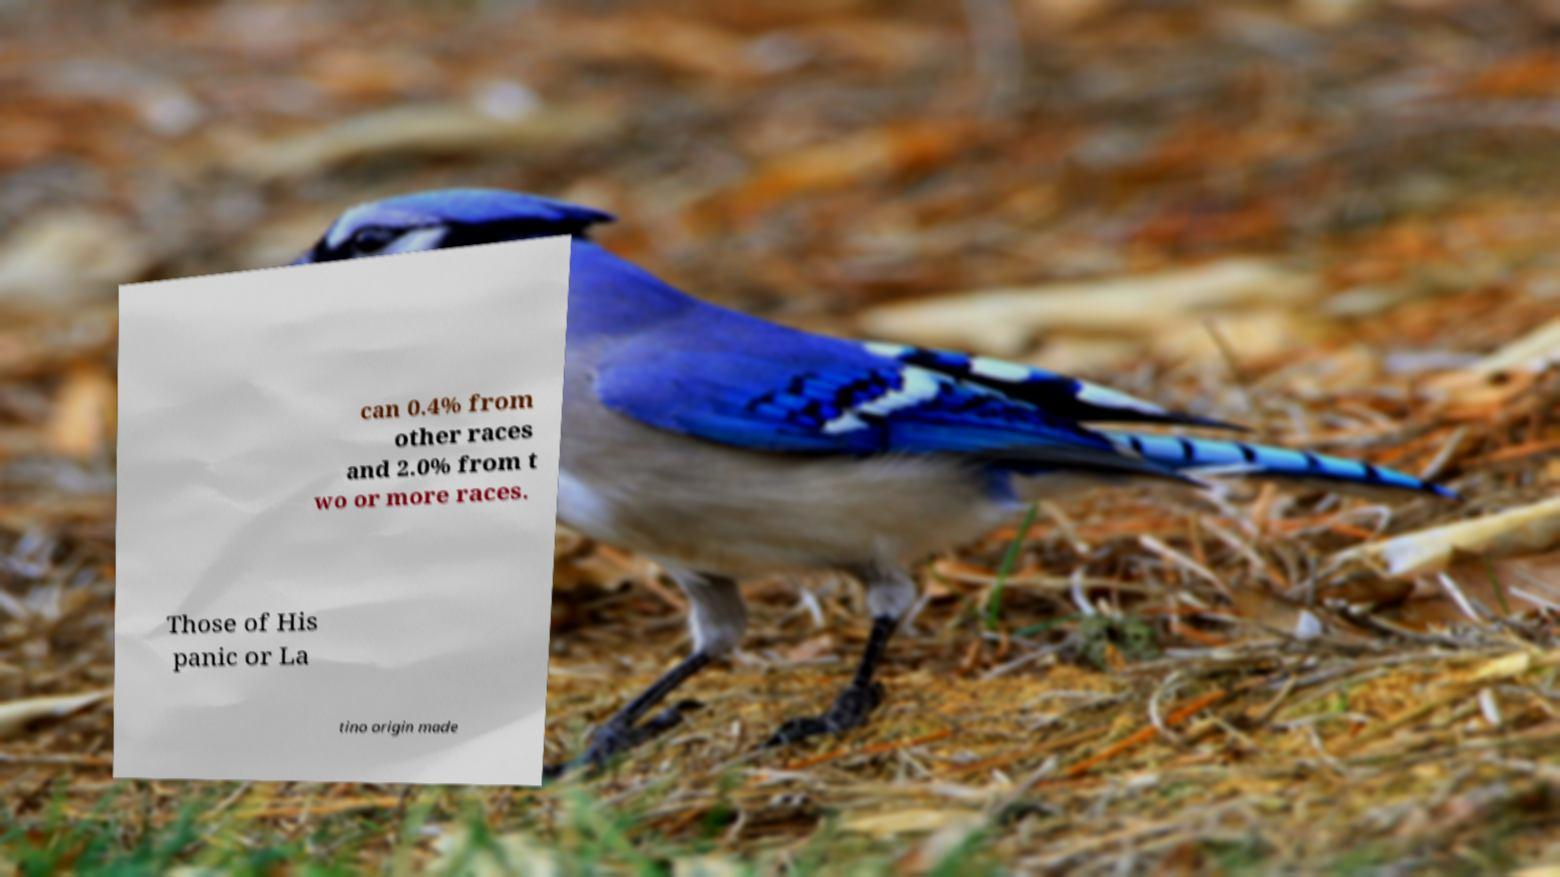Please read and relay the text visible in this image. What does it say? can 0.4% from other races and 2.0% from t wo or more races. Those of His panic or La tino origin made 